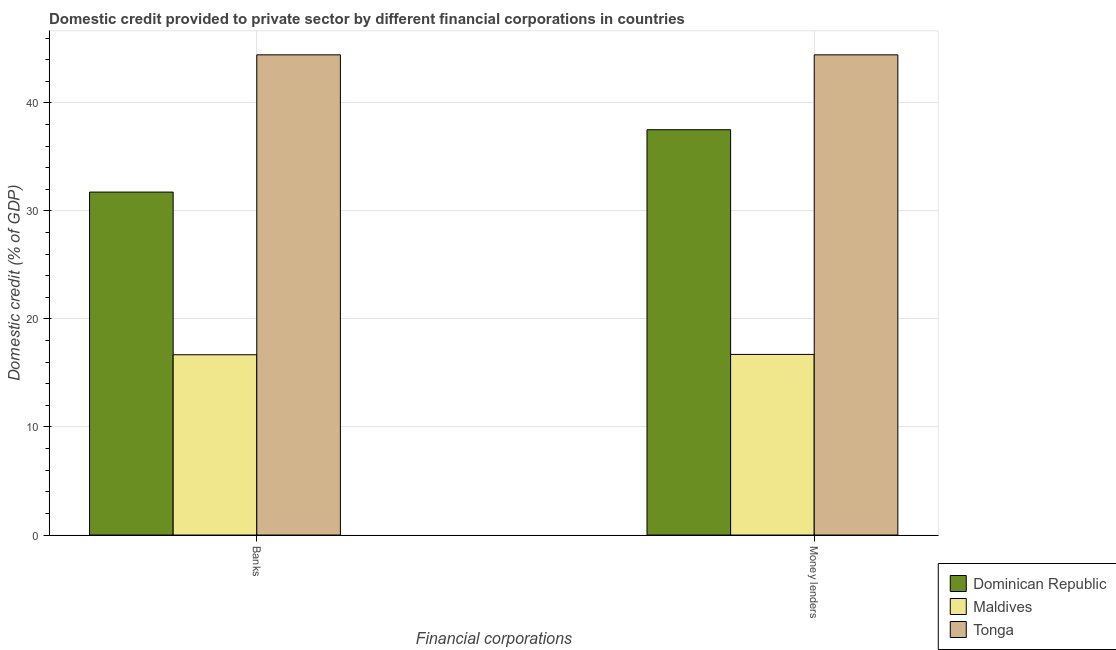How many different coloured bars are there?
Your answer should be very brief. 3. How many groups of bars are there?
Make the answer very short. 2. Are the number of bars per tick equal to the number of legend labels?
Offer a terse response. Yes. What is the label of the 1st group of bars from the left?
Offer a very short reply. Banks. What is the domestic credit provided by money lenders in Maldives?
Your answer should be compact. 16.72. Across all countries, what is the maximum domestic credit provided by banks?
Make the answer very short. 44.44. Across all countries, what is the minimum domestic credit provided by money lenders?
Provide a short and direct response. 16.72. In which country was the domestic credit provided by money lenders maximum?
Give a very brief answer. Tonga. In which country was the domestic credit provided by money lenders minimum?
Your response must be concise. Maldives. What is the total domestic credit provided by banks in the graph?
Your answer should be very brief. 92.87. What is the difference between the domestic credit provided by money lenders in Tonga and that in Dominican Republic?
Make the answer very short. 6.93. What is the difference between the domestic credit provided by money lenders in Dominican Republic and the domestic credit provided by banks in Tonga?
Give a very brief answer. -6.93. What is the average domestic credit provided by banks per country?
Offer a very short reply. 30.96. What is the difference between the domestic credit provided by banks and domestic credit provided by money lenders in Tonga?
Ensure brevity in your answer.  0. In how many countries, is the domestic credit provided by money lenders greater than 14 %?
Provide a short and direct response. 3. What is the ratio of the domestic credit provided by money lenders in Tonga to that in Maldives?
Your response must be concise. 2.66. In how many countries, is the domestic credit provided by banks greater than the average domestic credit provided by banks taken over all countries?
Provide a succinct answer. 2. What does the 3rd bar from the left in Banks represents?
Provide a succinct answer. Tonga. What does the 3rd bar from the right in Banks represents?
Provide a short and direct response. Dominican Republic. How many bars are there?
Provide a short and direct response. 6. How many countries are there in the graph?
Your answer should be very brief. 3. What is the difference between two consecutive major ticks on the Y-axis?
Provide a short and direct response. 10. Are the values on the major ticks of Y-axis written in scientific E-notation?
Ensure brevity in your answer.  No. Does the graph contain any zero values?
Provide a short and direct response. No. Does the graph contain grids?
Offer a terse response. Yes. What is the title of the graph?
Your answer should be very brief. Domestic credit provided to private sector by different financial corporations in countries. Does "Korea (Republic)" appear as one of the legend labels in the graph?
Offer a very short reply. No. What is the label or title of the X-axis?
Make the answer very short. Financial corporations. What is the label or title of the Y-axis?
Give a very brief answer. Domestic credit (% of GDP). What is the Domestic credit (% of GDP) of Dominican Republic in Banks?
Your answer should be very brief. 31.74. What is the Domestic credit (% of GDP) in Maldives in Banks?
Ensure brevity in your answer.  16.69. What is the Domestic credit (% of GDP) of Tonga in Banks?
Ensure brevity in your answer.  44.44. What is the Domestic credit (% of GDP) of Dominican Republic in Money lenders?
Ensure brevity in your answer.  37.51. What is the Domestic credit (% of GDP) in Maldives in Money lenders?
Offer a terse response. 16.72. What is the Domestic credit (% of GDP) in Tonga in Money lenders?
Provide a short and direct response. 44.44. Across all Financial corporations, what is the maximum Domestic credit (% of GDP) of Dominican Republic?
Offer a terse response. 37.51. Across all Financial corporations, what is the maximum Domestic credit (% of GDP) in Maldives?
Your answer should be compact. 16.72. Across all Financial corporations, what is the maximum Domestic credit (% of GDP) of Tonga?
Ensure brevity in your answer.  44.44. Across all Financial corporations, what is the minimum Domestic credit (% of GDP) in Dominican Republic?
Ensure brevity in your answer.  31.74. Across all Financial corporations, what is the minimum Domestic credit (% of GDP) of Maldives?
Provide a succinct answer. 16.69. Across all Financial corporations, what is the minimum Domestic credit (% of GDP) in Tonga?
Offer a very short reply. 44.44. What is the total Domestic credit (% of GDP) of Dominican Republic in the graph?
Keep it short and to the point. 69.25. What is the total Domestic credit (% of GDP) of Maldives in the graph?
Provide a short and direct response. 33.4. What is the total Domestic credit (% of GDP) of Tonga in the graph?
Keep it short and to the point. 88.89. What is the difference between the Domestic credit (% of GDP) of Dominican Republic in Banks and that in Money lenders?
Keep it short and to the point. -5.77. What is the difference between the Domestic credit (% of GDP) of Maldives in Banks and that in Money lenders?
Provide a succinct answer. -0.03. What is the difference between the Domestic credit (% of GDP) of Tonga in Banks and that in Money lenders?
Make the answer very short. 0. What is the difference between the Domestic credit (% of GDP) in Dominican Republic in Banks and the Domestic credit (% of GDP) in Maldives in Money lenders?
Your response must be concise. 15.02. What is the difference between the Domestic credit (% of GDP) in Dominican Republic in Banks and the Domestic credit (% of GDP) in Tonga in Money lenders?
Provide a succinct answer. -12.7. What is the difference between the Domestic credit (% of GDP) of Maldives in Banks and the Domestic credit (% of GDP) of Tonga in Money lenders?
Provide a succinct answer. -27.76. What is the average Domestic credit (% of GDP) in Dominican Republic per Financial corporations?
Your answer should be compact. 34.63. What is the average Domestic credit (% of GDP) in Maldives per Financial corporations?
Ensure brevity in your answer.  16.7. What is the average Domestic credit (% of GDP) of Tonga per Financial corporations?
Offer a very short reply. 44.44. What is the difference between the Domestic credit (% of GDP) of Dominican Republic and Domestic credit (% of GDP) of Maldives in Banks?
Your answer should be compact. 15.05. What is the difference between the Domestic credit (% of GDP) of Dominican Republic and Domestic credit (% of GDP) of Tonga in Banks?
Offer a very short reply. -12.7. What is the difference between the Domestic credit (% of GDP) of Maldives and Domestic credit (% of GDP) of Tonga in Banks?
Your answer should be very brief. -27.76. What is the difference between the Domestic credit (% of GDP) of Dominican Republic and Domestic credit (% of GDP) of Maldives in Money lenders?
Provide a short and direct response. 20.8. What is the difference between the Domestic credit (% of GDP) of Dominican Republic and Domestic credit (% of GDP) of Tonga in Money lenders?
Your answer should be very brief. -6.93. What is the difference between the Domestic credit (% of GDP) of Maldives and Domestic credit (% of GDP) of Tonga in Money lenders?
Provide a succinct answer. -27.73. What is the ratio of the Domestic credit (% of GDP) in Dominican Republic in Banks to that in Money lenders?
Provide a succinct answer. 0.85. What is the difference between the highest and the second highest Domestic credit (% of GDP) in Dominican Republic?
Give a very brief answer. 5.77. What is the difference between the highest and the second highest Domestic credit (% of GDP) in Maldives?
Ensure brevity in your answer.  0.03. What is the difference between the highest and the lowest Domestic credit (% of GDP) of Dominican Republic?
Your answer should be compact. 5.77. What is the difference between the highest and the lowest Domestic credit (% of GDP) of Maldives?
Offer a very short reply. 0.03. What is the difference between the highest and the lowest Domestic credit (% of GDP) in Tonga?
Your answer should be compact. 0. 